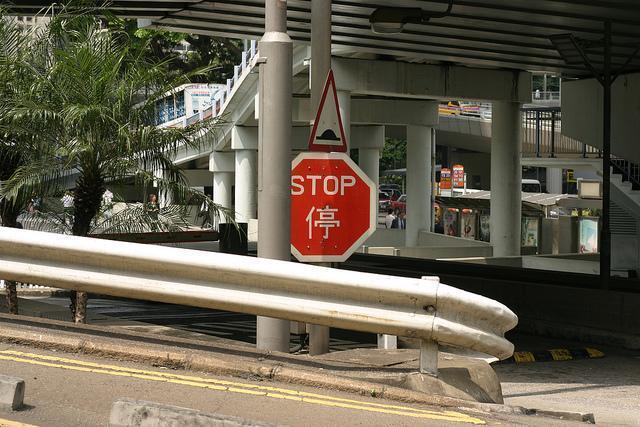How many people in the boat are wearing life jackets?
Give a very brief answer. 0. 